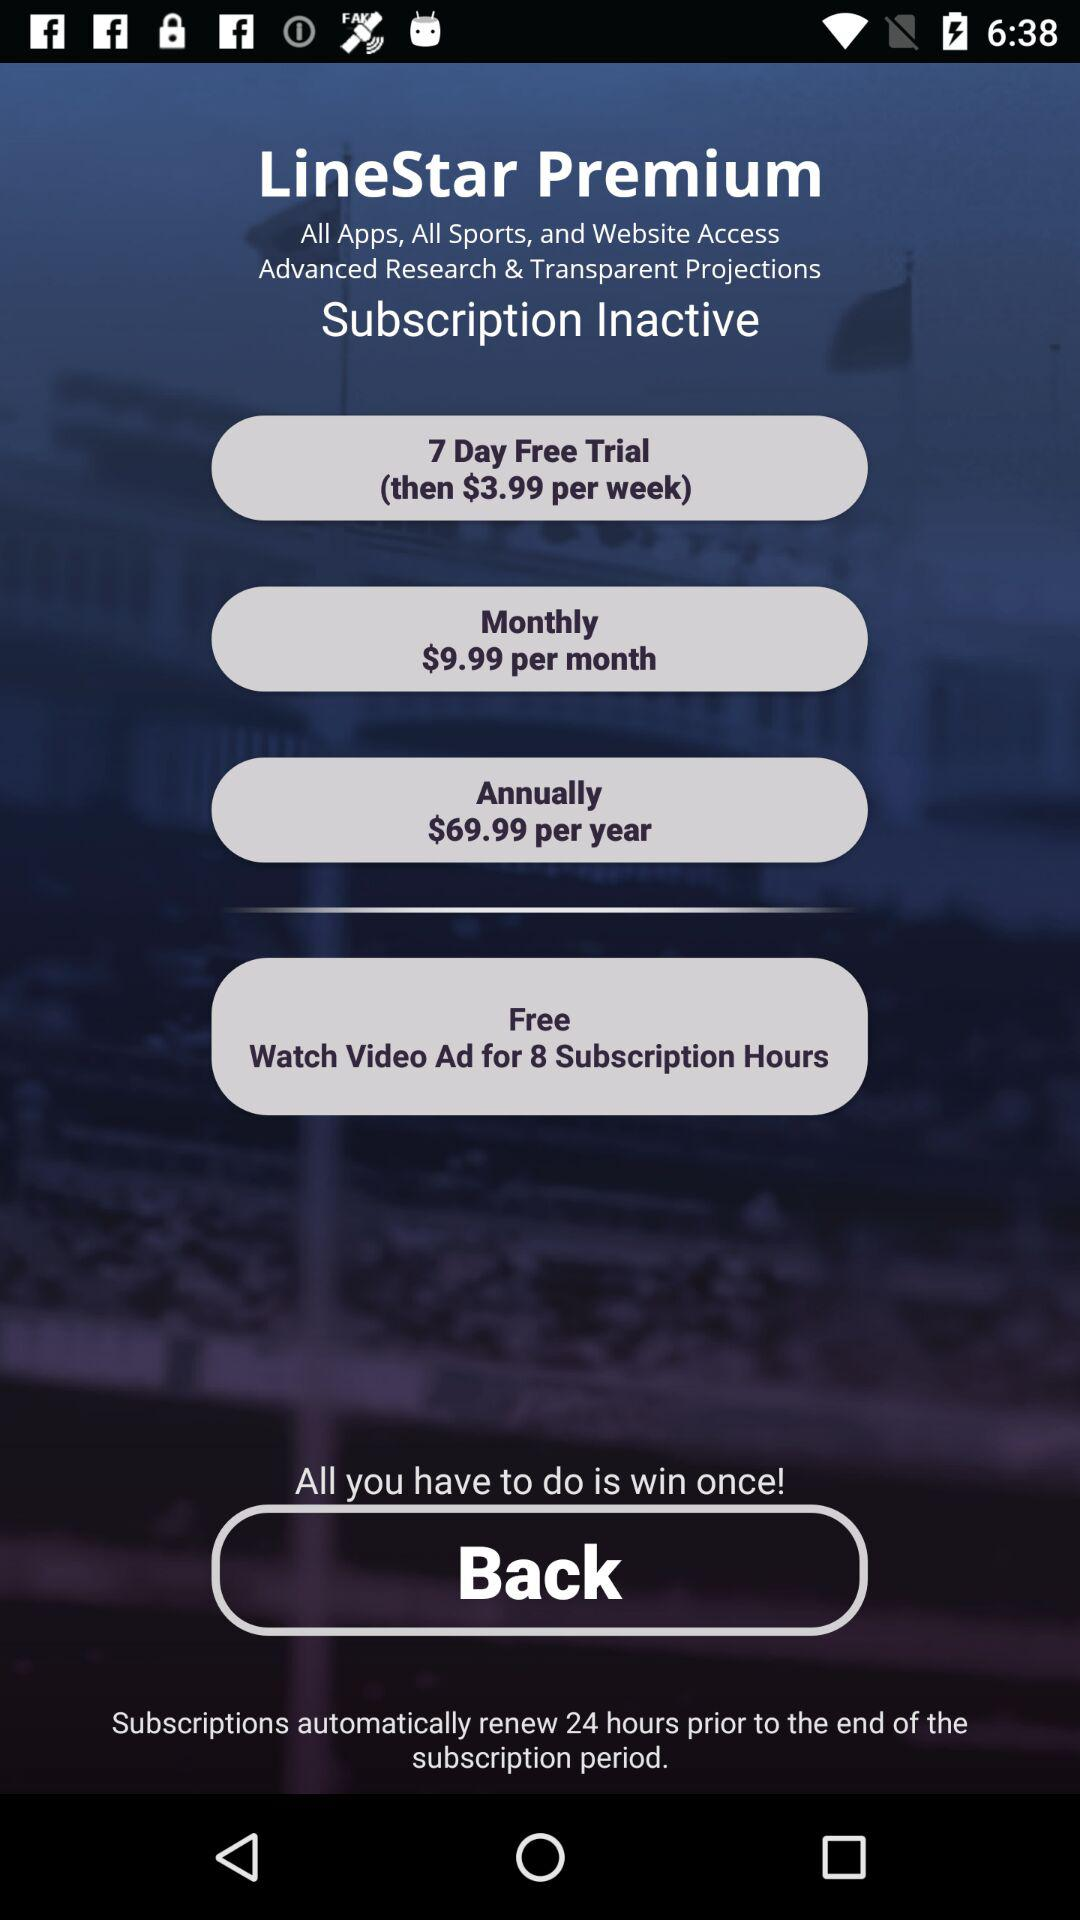What is the price after the free trial? The price after the free trial is $3.99 per week. 